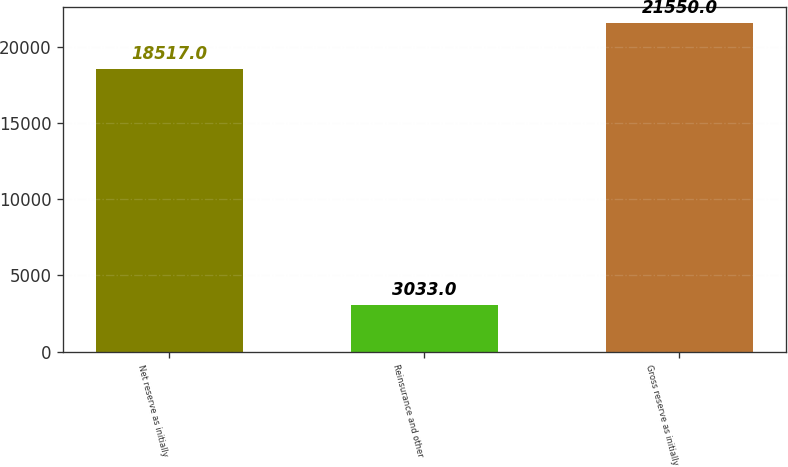Convert chart to OTSL. <chart><loc_0><loc_0><loc_500><loc_500><bar_chart><fcel>Net reserve as initially<fcel>Reinsurance and other<fcel>Gross reserve as initially<nl><fcel>18517<fcel>3033<fcel>21550<nl></chart> 